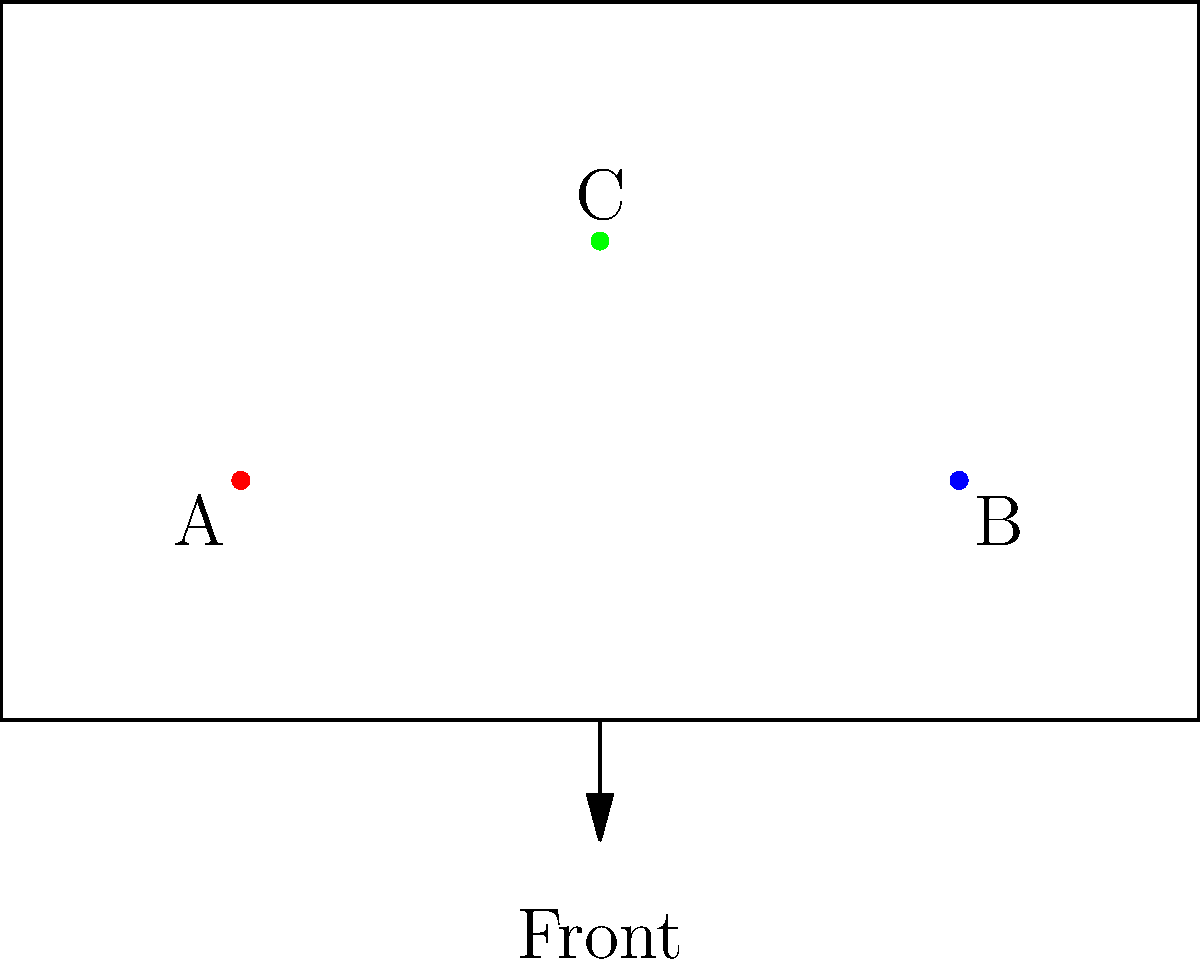Given the circuit board diagram with connection points A, B, and C, which of the following orientations correctly represents the board when viewed from the back?

1) A on the right, B on the left, C at the bottom
2) A on the left, B on the right, C at the top
3) B on the left, A on the right, C at the bottom
4) B on the right, A on the left, C at the top To solve this problem, we need to follow these steps:

1. Understand the current orientation:
   - The diagram shows the front view of the circuit board.
   - Point A is on the left, B is on the right, and C is at the top.

2. Visualize flipping the board:
   - Imagine flipping the board horizontally, as if viewing it from the back.

3. Analyze the new positions:
   - After flipping, left becomes right and right becomes left.
   - A will move to the right side.
   - B will move to the left side.
   - C will remain at the top, as we're flipping horizontally, not vertically.

4. Match the new orientation to the given options:
   - The correct orientation after flipping is: B on the left, A on the right, C at the top.

5. Select the matching answer:
   - Option 3 matches this description, except for C's position.
   - Option 2 perfectly matches the correct back view orientation.

Therefore, the correct answer is option 2: A on the left, B on the right, C at the top.
Answer: 2 